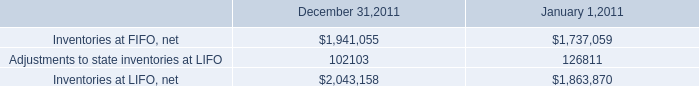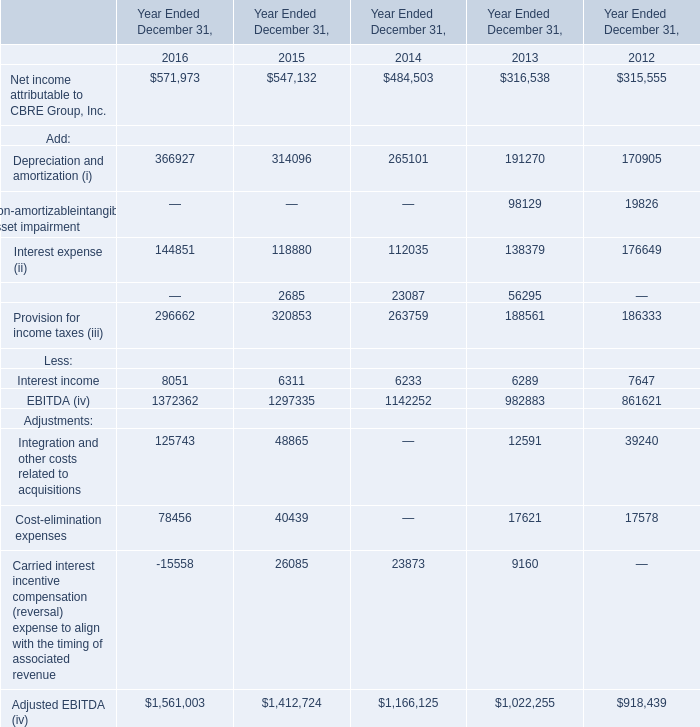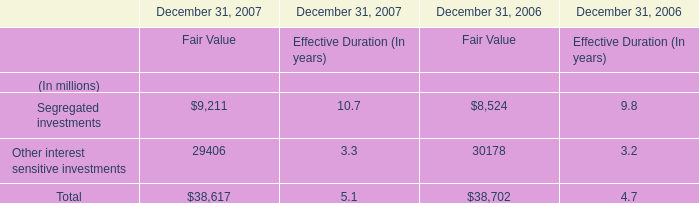What is the sum of Adjustments to state inventories at LIFO of January 1,2011, and Segregated investments of December 31, 2006 Fair Value ? 
Computations: (126811.0 + 8524.0)
Answer: 135335.0. 